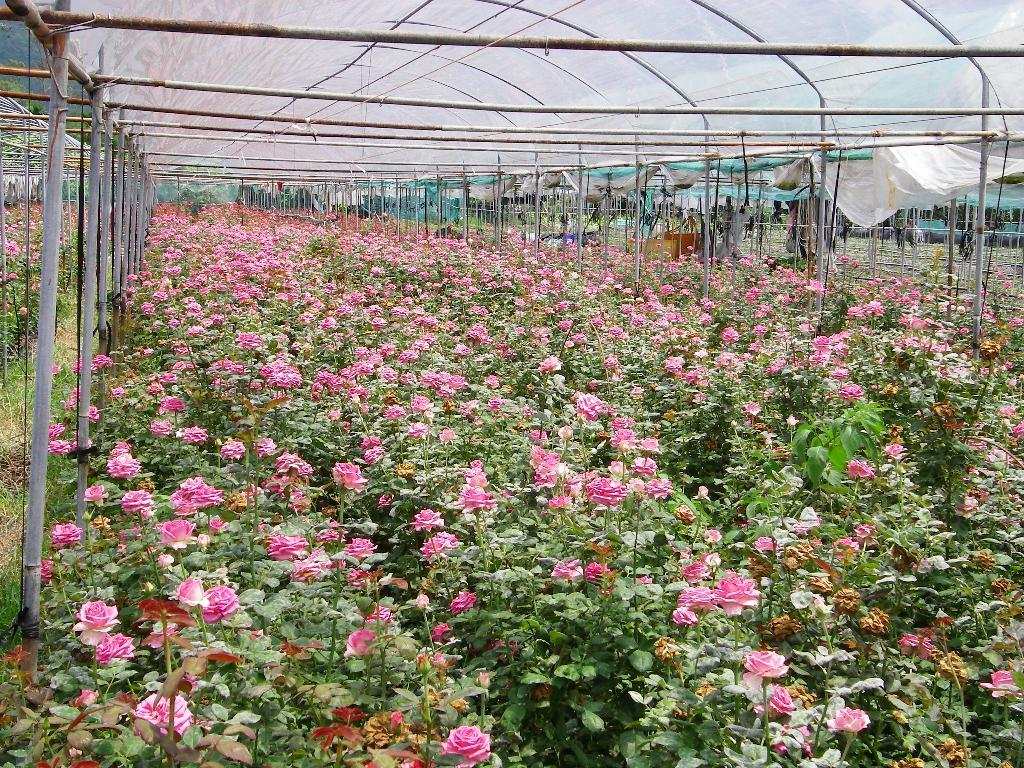What type of living organisms can be seen in the image? Plants and flowers are visible in the image. What structures are present in the image? There are sheds and poles in the image. What can be seen in the background of the image? Leaves are visible in the background of the image. Who is wearing a crown in the image? There is no person wearing a crown in the image; it features plants, flowers, sheds, and poles. How many toes can be seen in the image? There are no toes visible in the image, as it does not depict any people or animals. 